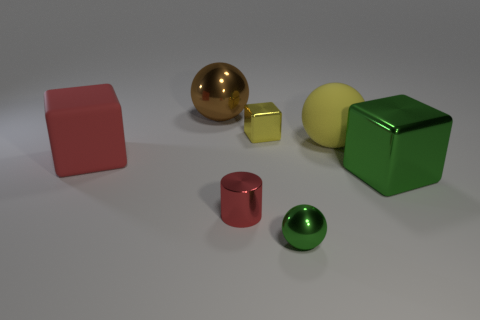Add 2 blocks. How many objects exist? 9 Subtract all cubes. How many objects are left? 4 Add 6 yellow spheres. How many yellow spheres exist? 7 Subtract 0 brown cubes. How many objects are left? 7 Subtract all red objects. Subtract all metallic balls. How many objects are left? 3 Add 2 large things. How many large things are left? 6 